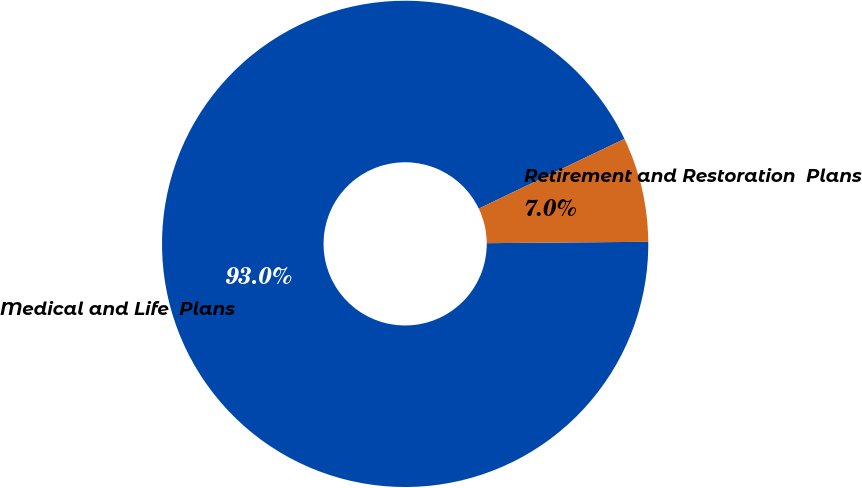Convert chart. <chart><loc_0><loc_0><loc_500><loc_500><pie_chart><fcel>Medical and Life  Plans<fcel>Retirement and Restoration  Plans<nl><fcel>93.03%<fcel>6.97%<nl></chart> 